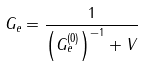<formula> <loc_0><loc_0><loc_500><loc_500>G _ { e } = \frac { 1 } { \left ( G _ { e } ^ { ( 0 ) } \right ) ^ { - 1 } + V }</formula> 